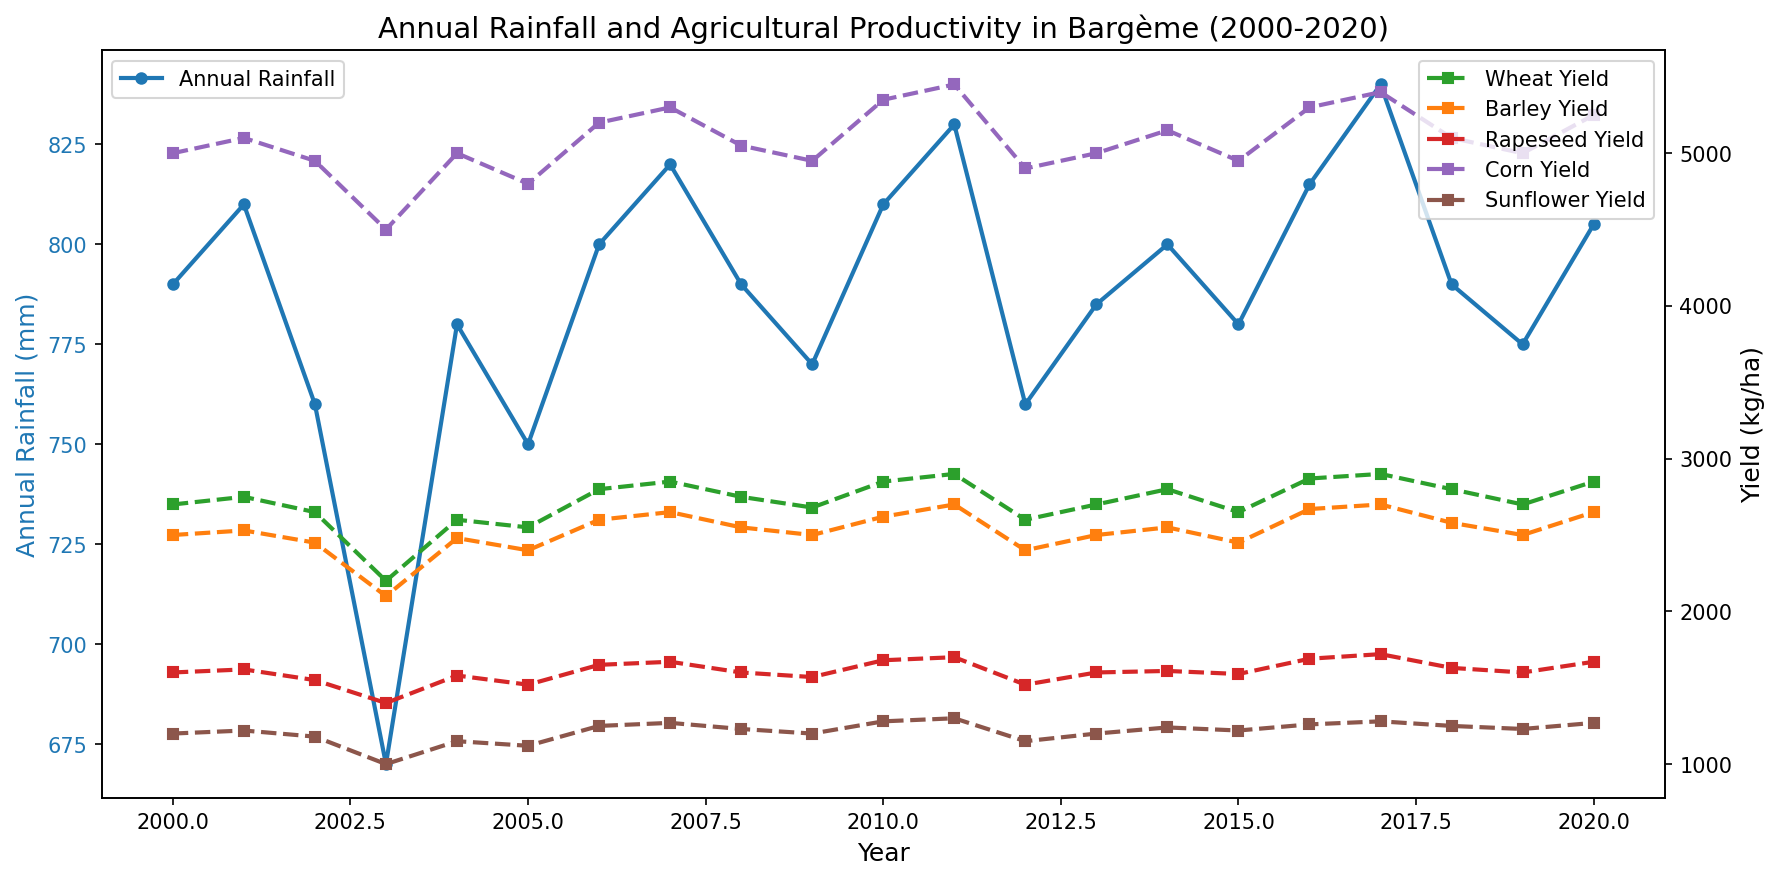What's the overall trend of the annual rainfall from 2000 to 2020? To identify the trend, observe the general direction of the blue line representing annual rainfall across the timeline from 2000 to 2020. It fluctuates but appears to be generally stable without a sharp increase or decrease.
Answer: Stable Which crop had the highest yield in 2010, and what was the value? Look at the year 2010 in the graph and compare the heights of the lines corresponding to different crops. The line with the highest point for this year is Corn Yield, colored in purple, with a yield value of 5350 kg/ha.
Answer: Corn Yield, 5350 kg/ha In which year was the difference between Wheat and Barley yields the smallest? Identify the years where the green (Wheat) and orange (Barley) lines are closest together. This visual comparison shows that in 2003, the yields are the closest with minimal difference between them.
Answer: 2003 Which crop showed the most consistent yield over the years? Assess the graphs to see which colored line shows the least fluctuation from year to year. The Sunflower Yield line, in brown, fluctuates the least, indicating consistent yields.
Answer: Sunflower Yield How does the annual rainfall in 2003 compare to other years, and what is the effect on crop yields? 2003 shows the lowest annual rainfall (670 mm). This appears to affect yields negatively, as most crops (Wheat, Barley, Rapeseed, Corn, Sunflower) have lower yields compared to other years.
Answer: Lowest rainfall, lower yields What was the average annual rainfall from 2000 to 2020? Sum the annual rainfall from 2000 to 2020 and then divide by the number of years. The calculation involves summing all yearly rainfall values and dividing by 21.
Answer: 789.76 mm Which crop had the highest yield improvement from 2000 to 2020? Compare the endpoints of the lines representing each crop's yield in 2000 and 2020. The Corn Yield line (purple) shows the most significant improvement, rising from 5000 kg/ha to 5250 kg/ha.
Answer: Corn Yield Is there a year where all crop yields decreased, and how does this relate to annual rainfall? Scan through the years to see if all yield lines drop simultaneously. In 2012, the yields for all crops decreased. This corresponds to the annual rainfall decreasing to 760 mm, below the general average.
Answer: 2012, lower rainfall What colors represented the highest and lowest yielding crops in 2020? Refer to the overall trend for 2020 and identify the highest and lowest yield lines. The highest yielding crop is Corn (purple), and the lowest is Sunflower (brown).
Answer: Purple and Brown What is the trend relationship between annual rainfall and Sunflower yield? Analyze the blue line for annual rainfall and the brown line for Sunflower yield to see any apparent correlation. Sunflower yield seems relatively stable regardless of annual rainfall fluctuations, indicating no strong correlation.
Answer: No strong correlation 